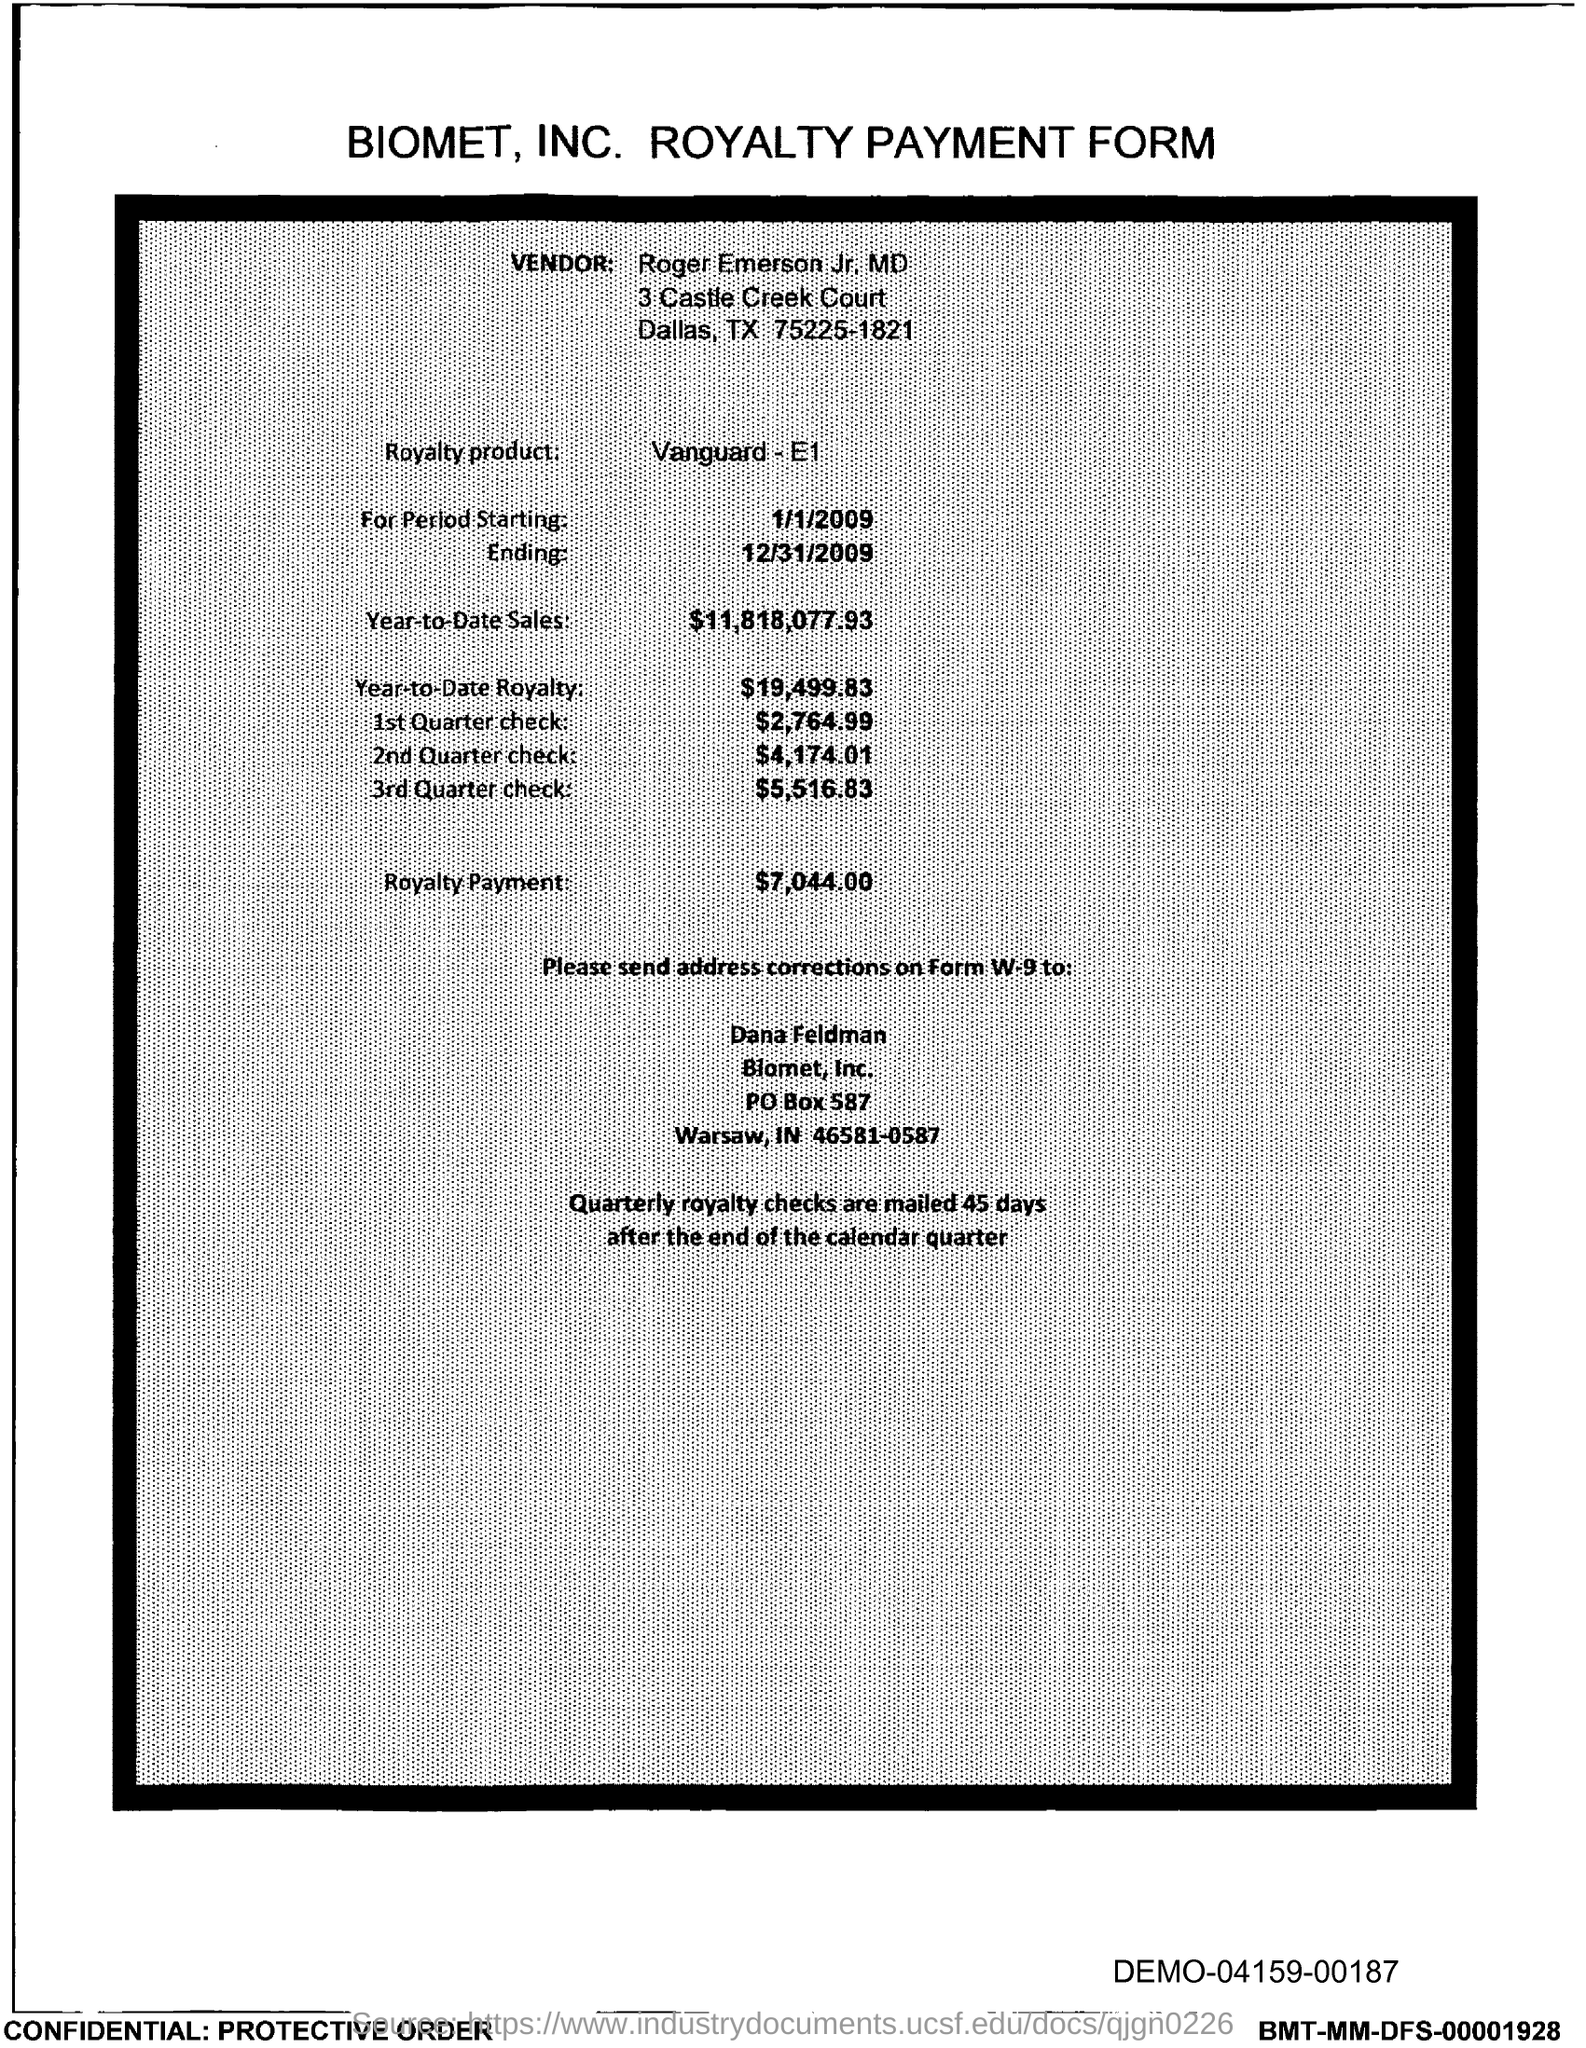In which state biomet, inc. located?
Give a very brief answer. IN. What is the royalty product name ?
Provide a succinct answer. Vanguard-E1. What is the date for period  starting?
Your answer should be very brief. 1/1/2009. What is the date of ending ?
Keep it short and to the point. 12/31/2009. What is the year-to-date sales?
Provide a succinct answer. $11,818,077.93. What is the year-to-date royalty ?
Offer a terse response. $19,499.83. What is the royalty payment ?
Your answer should be compact. $7,044.00. What is the po box no. of biomet, inc.?
Offer a very short reply. 587. 